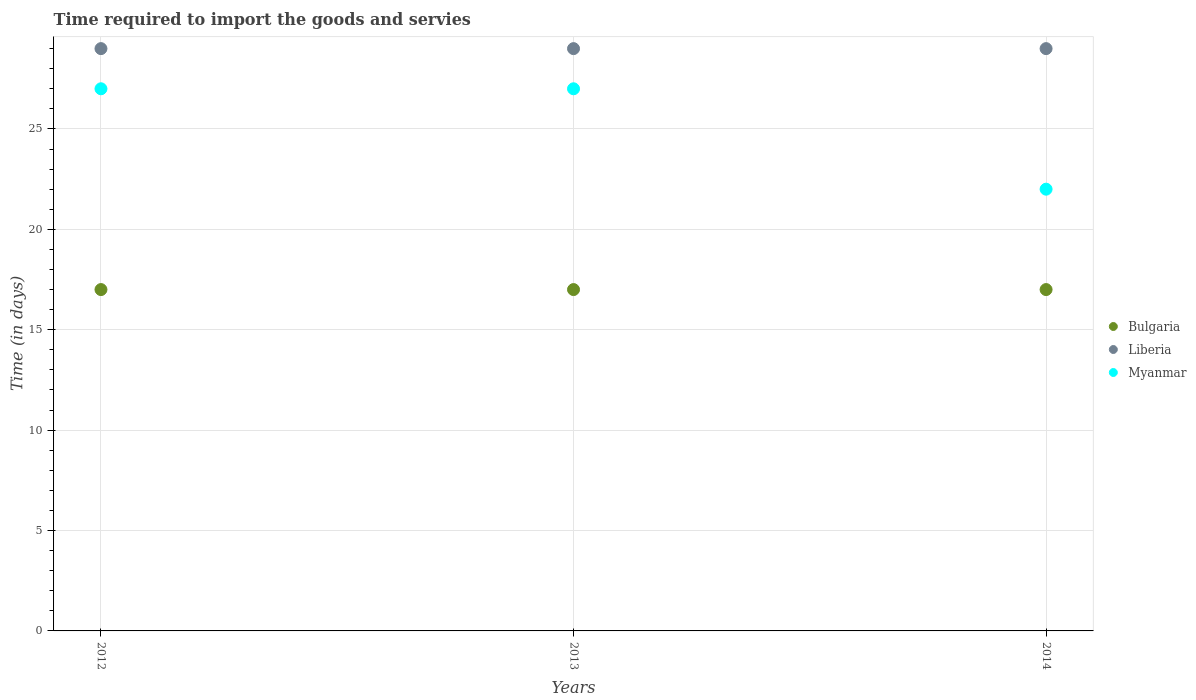What is the total number of days required to import the goods and services in Bulgaria in the graph?
Give a very brief answer. 51. What is the average number of days required to import the goods and services in Bulgaria per year?
Your answer should be compact. 17. In how many years, is the number of days required to import the goods and services in Bulgaria greater than 10 days?
Keep it short and to the point. 3. What is the ratio of the number of days required to import the goods and services in Liberia in 2013 to that in 2014?
Your answer should be compact. 1. Is the number of days required to import the goods and services in Myanmar in 2012 less than that in 2014?
Offer a terse response. No. Is the difference between the number of days required to import the goods and services in Bulgaria in 2012 and 2013 greater than the difference between the number of days required to import the goods and services in Liberia in 2012 and 2013?
Provide a succinct answer. No. What is the difference between the highest and the second highest number of days required to import the goods and services in Myanmar?
Offer a very short reply. 0. What is the difference between the highest and the lowest number of days required to import the goods and services in Bulgaria?
Your answer should be compact. 0. In how many years, is the number of days required to import the goods and services in Liberia greater than the average number of days required to import the goods and services in Liberia taken over all years?
Your response must be concise. 0. Does the number of days required to import the goods and services in Liberia monotonically increase over the years?
Ensure brevity in your answer.  No. Is the number of days required to import the goods and services in Myanmar strictly less than the number of days required to import the goods and services in Liberia over the years?
Provide a succinct answer. Yes. How many dotlines are there?
Offer a very short reply. 3. How many years are there in the graph?
Give a very brief answer. 3. Does the graph contain any zero values?
Keep it short and to the point. No. Does the graph contain grids?
Make the answer very short. Yes. How many legend labels are there?
Your answer should be compact. 3. What is the title of the graph?
Make the answer very short. Time required to import the goods and servies. What is the label or title of the X-axis?
Keep it short and to the point. Years. What is the label or title of the Y-axis?
Ensure brevity in your answer.  Time (in days). What is the Time (in days) in Liberia in 2012?
Provide a succinct answer. 29. What is the Time (in days) in Myanmar in 2012?
Keep it short and to the point. 27. What is the Time (in days) in Bulgaria in 2013?
Your answer should be very brief. 17. What is the Time (in days) in Liberia in 2013?
Your response must be concise. 29. What is the Time (in days) of Liberia in 2014?
Keep it short and to the point. 29. What is the Time (in days) of Myanmar in 2014?
Your answer should be compact. 22. Across all years, what is the minimum Time (in days) of Liberia?
Give a very brief answer. 29. What is the total Time (in days) of Liberia in the graph?
Give a very brief answer. 87. What is the total Time (in days) of Myanmar in the graph?
Your response must be concise. 76. What is the difference between the Time (in days) in Myanmar in 2012 and that in 2014?
Your response must be concise. 5. What is the difference between the Time (in days) of Myanmar in 2013 and that in 2014?
Your response must be concise. 5. What is the difference between the Time (in days) of Bulgaria in 2012 and the Time (in days) of Liberia in 2013?
Your answer should be very brief. -12. What is the difference between the Time (in days) of Bulgaria in 2013 and the Time (in days) of Liberia in 2014?
Your answer should be compact. -12. What is the difference between the Time (in days) of Bulgaria in 2013 and the Time (in days) of Myanmar in 2014?
Provide a succinct answer. -5. What is the difference between the Time (in days) in Liberia in 2013 and the Time (in days) in Myanmar in 2014?
Provide a succinct answer. 7. What is the average Time (in days) of Bulgaria per year?
Make the answer very short. 17. What is the average Time (in days) in Myanmar per year?
Give a very brief answer. 25.33. In the year 2012, what is the difference between the Time (in days) in Bulgaria and Time (in days) in Liberia?
Your response must be concise. -12. In the year 2013, what is the difference between the Time (in days) in Bulgaria and Time (in days) in Liberia?
Your response must be concise. -12. In the year 2013, what is the difference between the Time (in days) in Liberia and Time (in days) in Myanmar?
Your answer should be very brief. 2. In the year 2014, what is the difference between the Time (in days) of Bulgaria and Time (in days) of Myanmar?
Keep it short and to the point. -5. In the year 2014, what is the difference between the Time (in days) of Liberia and Time (in days) of Myanmar?
Offer a terse response. 7. What is the ratio of the Time (in days) of Bulgaria in 2012 to that in 2013?
Provide a succinct answer. 1. What is the ratio of the Time (in days) of Bulgaria in 2012 to that in 2014?
Ensure brevity in your answer.  1. What is the ratio of the Time (in days) of Liberia in 2012 to that in 2014?
Your answer should be very brief. 1. What is the ratio of the Time (in days) in Myanmar in 2012 to that in 2014?
Give a very brief answer. 1.23. What is the ratio of the Time (in days) in Bulgaria in 2013 to that in 2014?
Offer a very short reply. 1. What is the ratio of the Time (in days) in Myanmar in 2013 to that in 2014?
Offer a terse response. 1.23. What is the difference between the highest and the second highest Time (in days) in Bulgaria?
Your answer should be compact. 0. What is the difference between the highest and the lowest Time (in days) of Liberia?
Offer a very short reply. 0. 